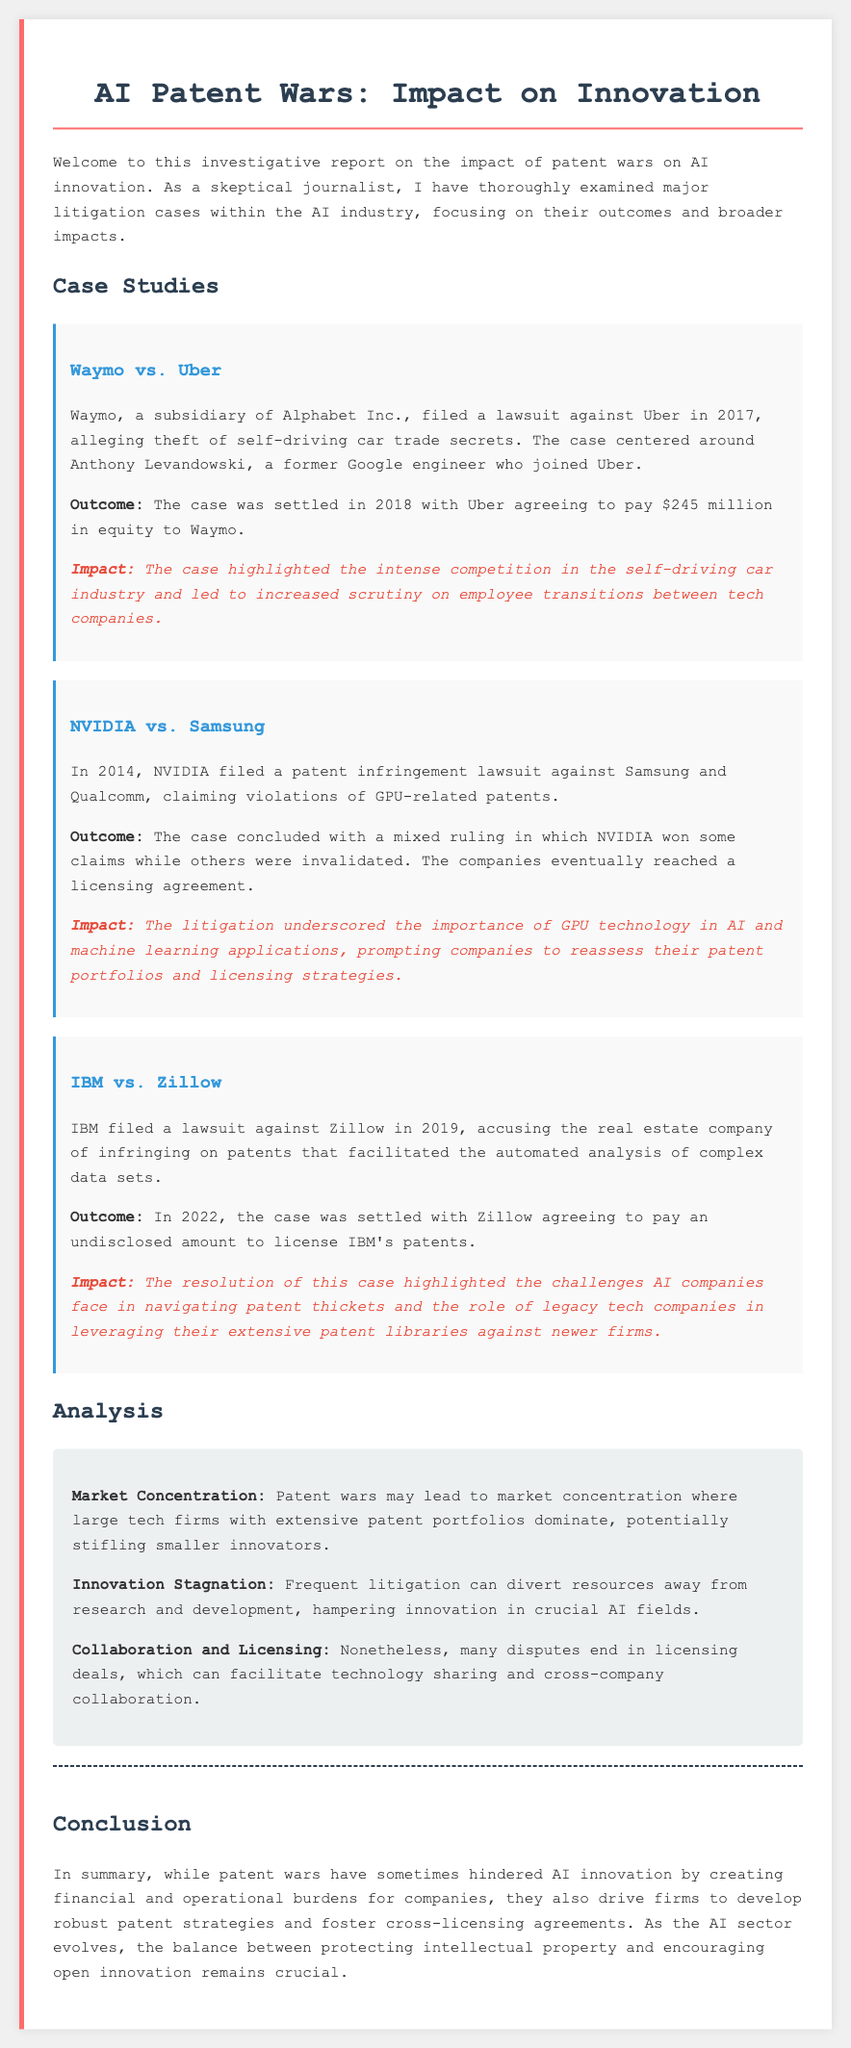What was the year when Waymo filed its lawsuit against Uber? The case was filed in 2017, as indicated in the document.
Answer: 2017 What amount did Uber agree to pay Waymo to settle the lawsuit? The document states that Uber agreed to pay $245 million in equity to Waymo.
Answer: $245 million What was the outcome of the NVIDIA vs. Samsung case? The outcome was a mixed ruling with some claims won by NVIDIA while others were invalidated, leading to a licensing agreement.
Answer: Mixed ruling What impact did the IBM vs. Zillow case highlight? The resolution highlighted the challenges AI companies face in navigating patent thickets.
Answer: Navigating patent thickets What does the analysis section suggest about the effect of frequent litigation on innovation? The analysis suggests that frequent litigation can divert resources away from research and development, hampering innovation.
Answer: Hampering innovation Which company sued Zillow in 2019? The document specifies that IBM filed a lawsuit against Zillow.
Answer: IBM What major issue do patent wars create according to the analysis? The analysis identifies market concentration as a major issue where large firms dominate, stifling smaller innovators.
Answer: Market concentration What is the main conclusion regarding the impact of patent wars on innovation? The conclusion states that patent wars can hinder AI innovation while also driving robust patent strategies.
Answer: Hinder innovation 